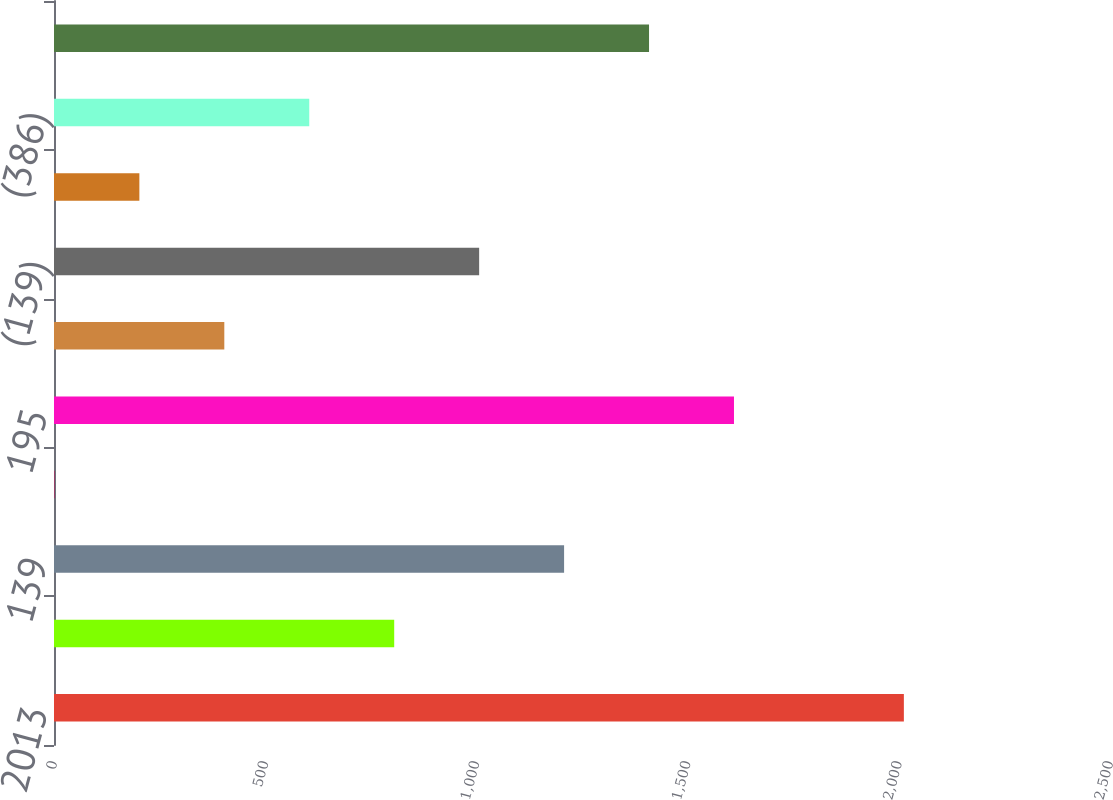Convert chart. <chart><loc_0><loc_0><loc_500><loc_500><bar_chart><fcel>2013<fcel>55<fcel>139<fcel>1<fcel>195<fcel>(243)<fcel>(139)<fcel>(4)<fcel>(386)<fcel>(191)<nl><fcel>2012<fcel>805.4<fcel>1207.6<fcel>1<fcel>1609.8<fcel>403.2<fcel>1006.5<fcel>202.1<fcel>604.3<fcel>1408.7<nl></chart> 